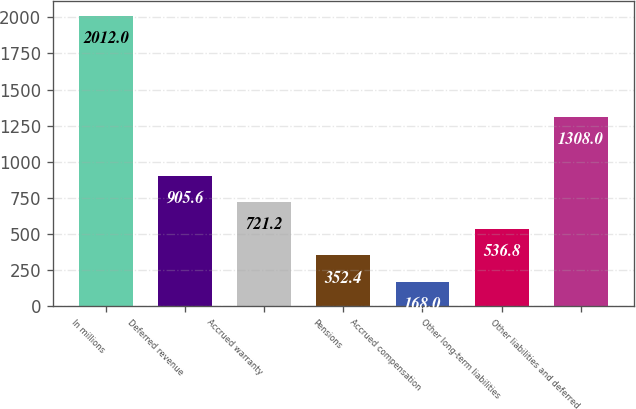Convert chart. <chart><loc_0><loc_0><loc_500><loc_500><bar_chart><fcel>In millions<fcel>Deferred revenue<fcel>Accrued warranty<fcel>Pensions<fcel>Accrued compensation<fcel>Other long-term liabilities<fcel>Other liabilities and deferred<nl><fcel>2012<fcel>905.6<fcel>721.2<fcel>352.4<fcel>168<fcel>536.8<fcel>1308<nl></chart> 